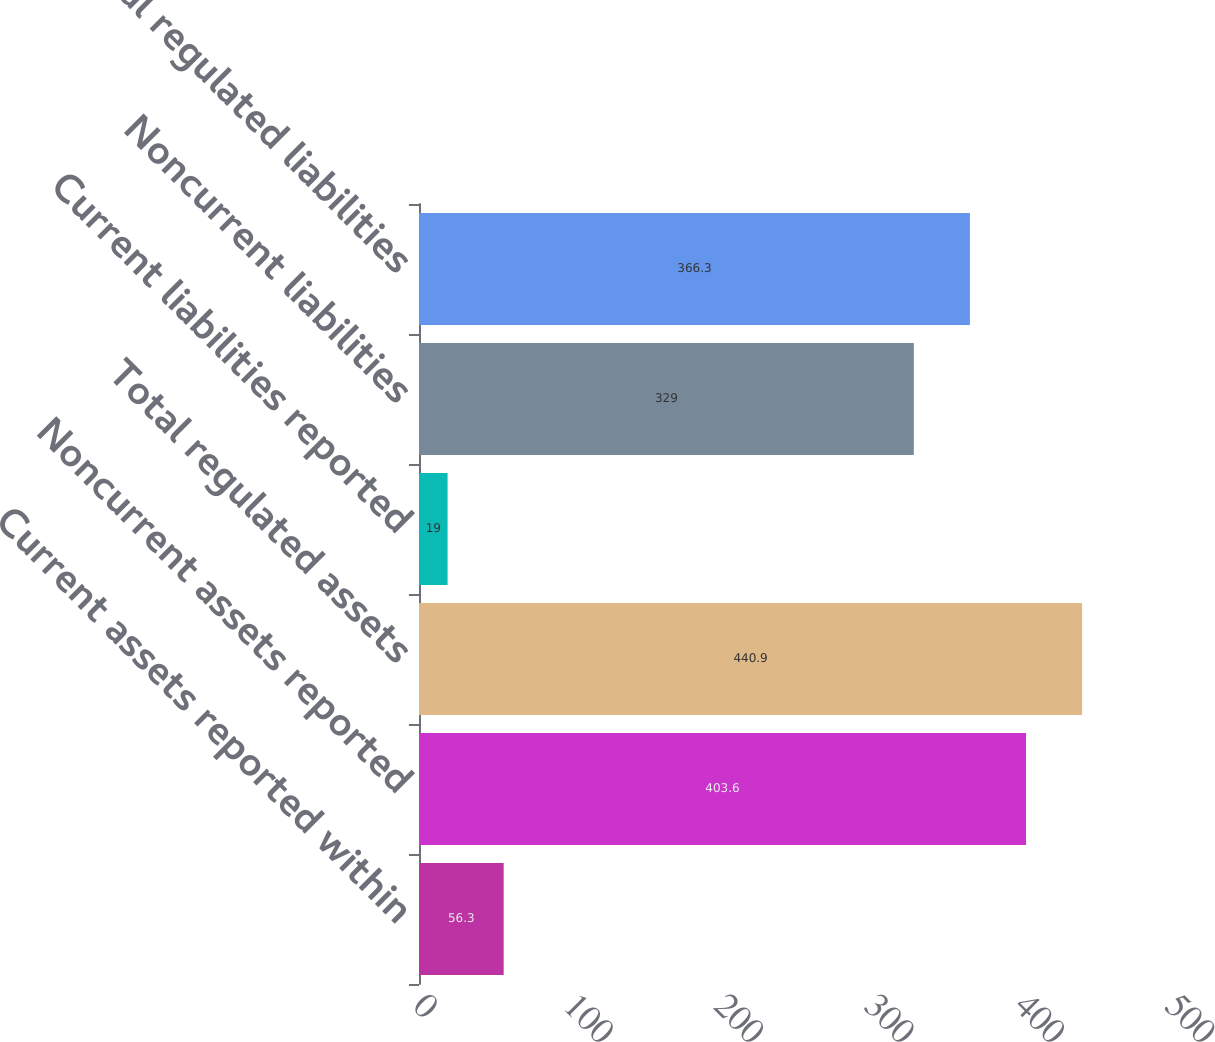Convert chart to OTSL. <chart><loc_0><loc_0><loc_500><loc_500><bar_chart><fcel>Current assets reported within<fcel>Noncurrent assets reported<fcel>Total regulated assets<fcel>Current liabilities reported<fcel>Noncurrent liabilities<fcel>Total regulated liabilities<nl><fcel>56.3<fcel>403.6<fcel>440.9<fcel>19<fcel>329<fcel>366.3<nl></chart> 